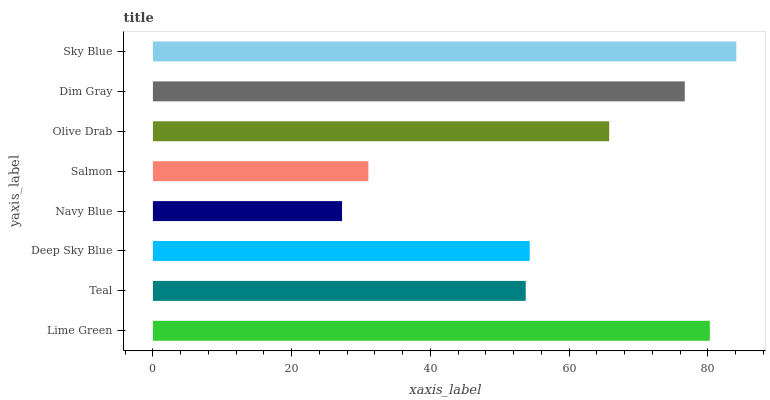Is Navy Blue the minimum?
Answer yes or no. Yes. Is Sky Blue the maximum?
Answer yes or no. Yes. Is Teal the minimum?
Answer yes or no. No. Is Teal the maximum?
Answer yes or no. No. Is Lime Green greater than Teal?
Answer yes or no. Yes. Is Teal less than Lime Green?
Answer yes or no. Yes. Is Teal greater than Lime Green?
Answer yes or no. No. Is Lime Green less than Teal?
Answer yes or no. No. Is Olive Drab the high median?
Answer yes or no. Yes. Is Deep Sky Blue the low median?
Answer yes or no. Yes. Is Sky Blue the high median?
Answer yes or no. No. Is Salmon the low median?
Answer yes or no. No. 